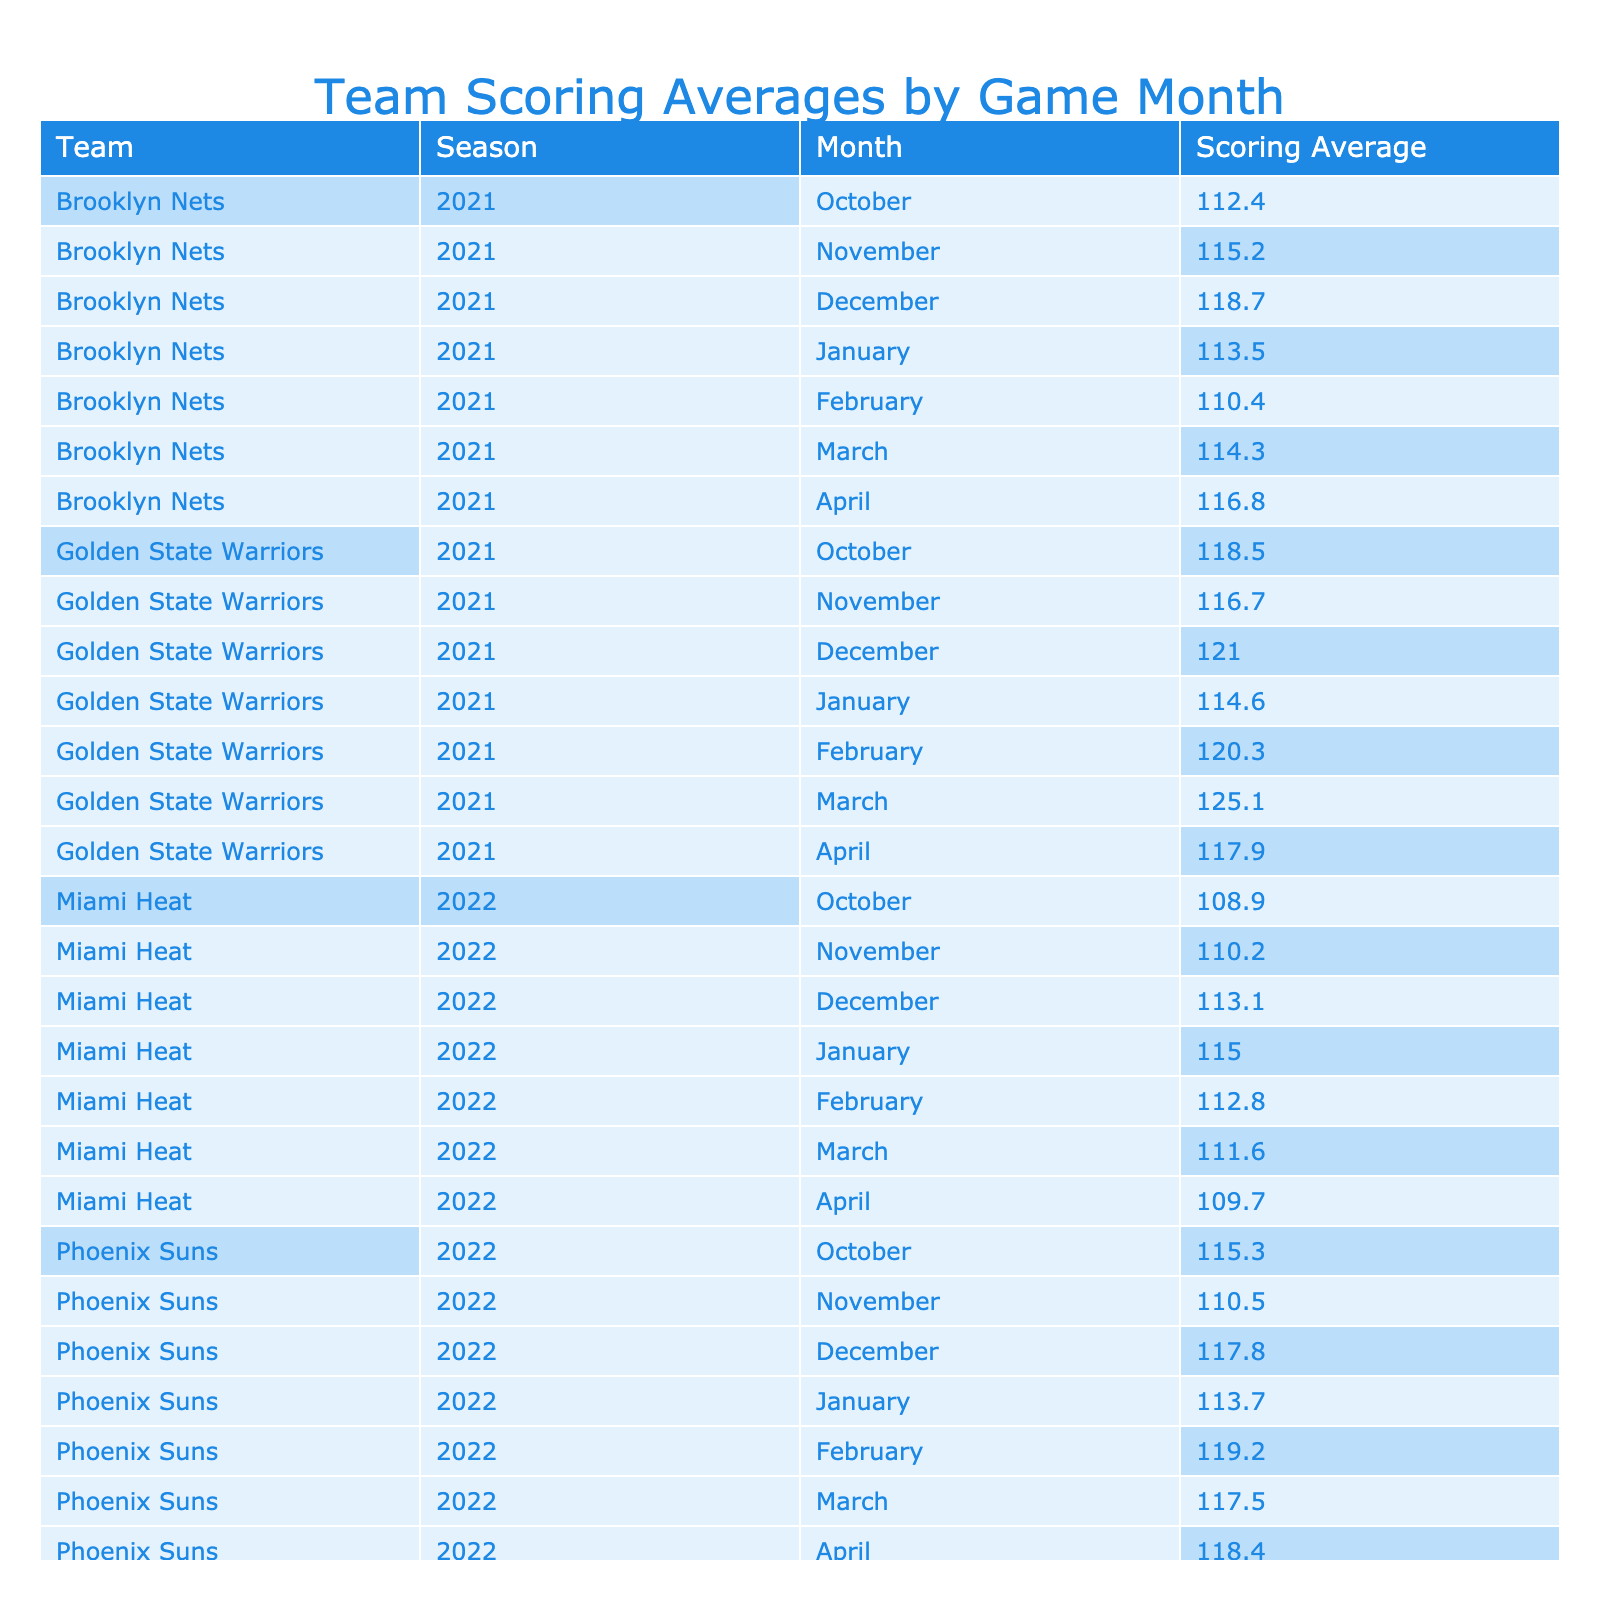What was the highest scoring average for the Golden State Warriors in a single month? By reviewing the table, we can see the scoring averages for the Golden State Warriors across different months. The highest average listed is 125.1 in March 2021.
Answer: 125.1 Which month had the lowest scoring average for the Miami Heat in the 2022 season? Looking at the Miami Heat's monthly scoring averages for the 2022 season, the lowest score is in April, with an average of 109.7.
Answer: 109.7 Did the Brooklyn Nets ever have a scoring average above 120 in any month during the 2021 season? In examining the Brooklyn Nets' scoring averages, we find that the highest monthly average is 118.7 in December 2021, which is not above 120. Therefore, the answer is no.
Answer: No What was the difference in scoring average between the highest and lowest months for the Milwaukee Bucks in the 2023 season? For the Milwaukee Bucks, the highest monthly average is 122.0 in April and the lowest is 117.0 in December. The difference is calculated as 122.0 - 117.0 = 5.0.
Answer: 5.0 Which team had the best scoring average in January 2023? By checking the Jan 2023 month values, the Los Angeles Lakers had a scoring average of 119.9, which is higher than the other teams listed for that month.
Answer: Los Angeles Lakers What is the average scoring average for the Phoenix Suns during the 2022 season? To find the average for the Phoenix Suns, we sum their monthly scoring averages: (115.3 + 110.5 + 117.8 + 113.7 + 119.2 + 117.5 + 118.4) = 812.4. Then, we divide by the total number of months, which is 7. Thus, 812.4 / 7 = approximately 116.1.
Answer: 116.1 Did the scoring average for the Golden State Warriors in December 2021 exceed the average of the Brooklyn Nets in the same month? Reviewing the table shows that the Golden State Warriors had a scoring average of 121.0 in December, while the Brooklyn Nets had an average of 118.7. Since 121.0 is greater than 118.7, the answer is yes.
Answer: Yes How many teams had a scoring average above 115 in February 2023? From the table, we check the February 2023 averages: Los Angeles Lakers scored 114.5, Milwaukee Bucks scored 115.6. Only the Milwaukee Bucks exceeded 115, making it a total of one team.
Answer: 1 What was the highest scoring average for the Miami Heat during the 2022 season? Looking through the monthly averages for the Miami Heat in 2022, the highest scoring average was 115.0 in January.
Answer: 115.0 